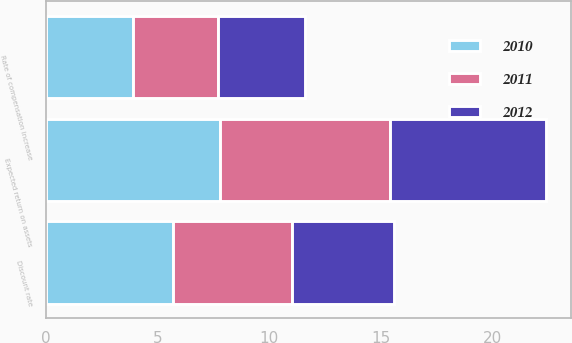Convert chart. <chart><loc_0><loc_0><loc_500><loc_500><stacked_bar_chart><ecel><fcel>Discount rate<fcel>Expected return on assets<fcel>Rate of compensation increase<nl><fcel>2012<fcel>4.6<fcel>7<fcel>3.9<nl><fcel>2011<fcel>5.3<fcel>7.6<fcel>3.8<nl><fcel>2010<fcel>5.7<fcel>7.8<fcel>3.9<nl></chart> 